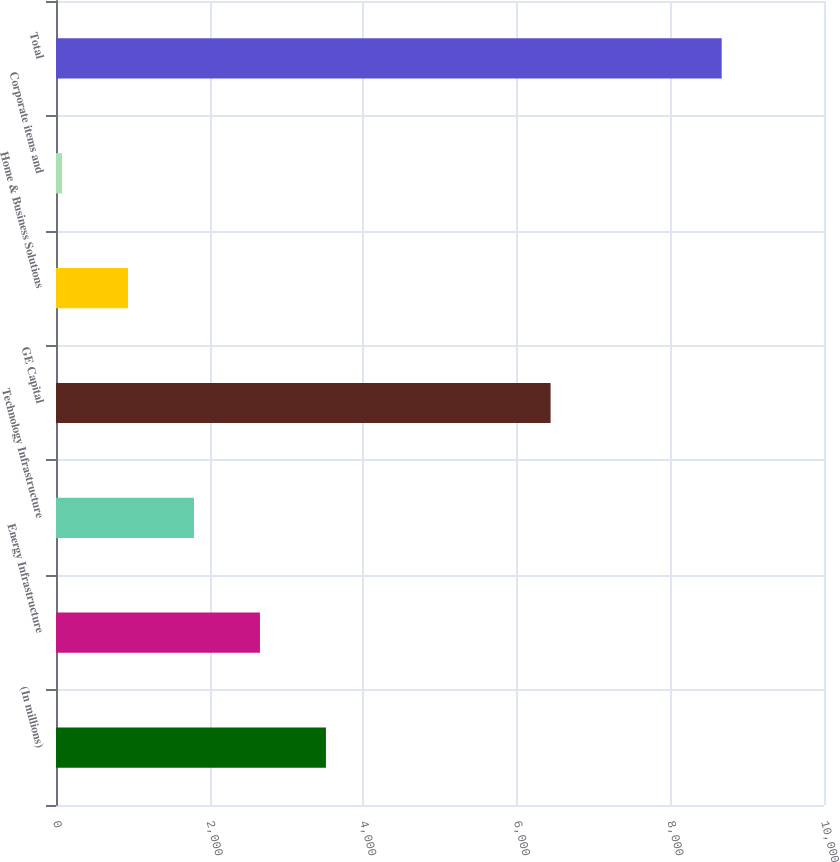<chart> <loc_0><loc_0><loc_500><loc_500><bar_chart><fcel>(In millions)<fcel>Energy Infrastructure<fcel>Technology Infrastructure<fcel>GE Capital<fcel>Home & Business Solutions<fcel>Corporate items and<fcel>Total<nl><fcel>3514.6<fcel>2655.7<fcel>1796.8<fcel>6440<fcel>937.9<fcel>79<fcel>8668<nl></chart> 